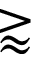Convert formula to latex. <formula><loc_0><loc_0><loc_500><loc_500>\gtrapprox</formula> 